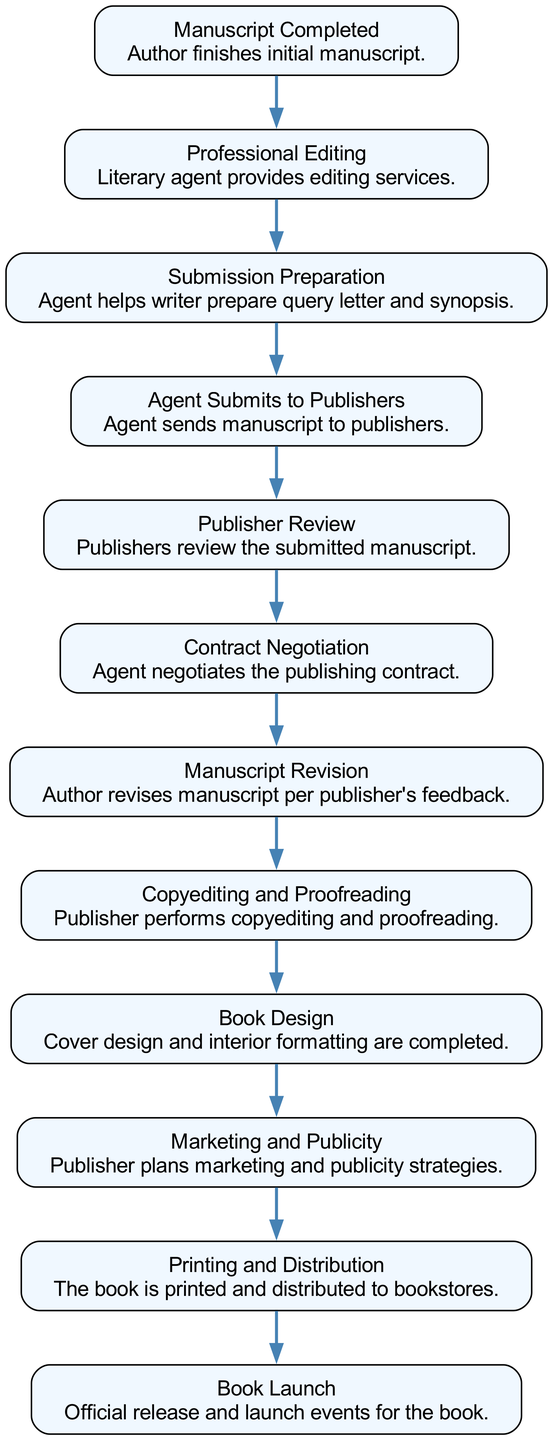What is the first stage in the book's journey? The first stage is "Manuscript Completed," indicating that this is where the author finishes the initial manuscript.
Answer: Manuscript Completed How many nodes are there in the diagram? The diagram includes 12 distinct nodes or stages in the book's journey, from the manuscript completion to the book launch.
Answer: 12 What follows after "Professional Editing"? After "Professional Editing," the next stage is "Submission Preparation," where the agent helps prepare the necessary materials for submission to publishers.
Answer: Submission Preparation Which stage comes before "Contract Negotiation"? "Publisher Review" comes before "Contract Negotiation," as publishers must first review the manuscript before negotiations can take place.
Answer: Publisher Review What is the final stage in the book's journey? The final stage is "Book Launch," which represents the official release and any associated launch events for the book.
Answer: Book Launch How many connections are there in the diagram? There are 11 connections in the diagram, representing the flow from one stage to the next throughout the book's journey.
Answer: 11 What is the purpose of the "Copyediting and Proofreading" stage? This stage involves the publisher performing copyediting and proofreading to ensure the manuscript is polished before publication.
Answer: Copyediting and Proofreading Which two stages are directly connected to "Manuscript Revision"? "Contract Negotiation" precedes "Manuscript Revision," and "Copyediting and Proofreading" follows it, showing the flow of work after revisions are made.
Answer: Contract Negotiation and Copyediting and Proofreading What is the main activity in the "Marketing and Publicity" stage? The main activity in this stage is planning marketing and publicity strategies to promote the book as it approaches publication.
Answer: Marketing and Publicity 